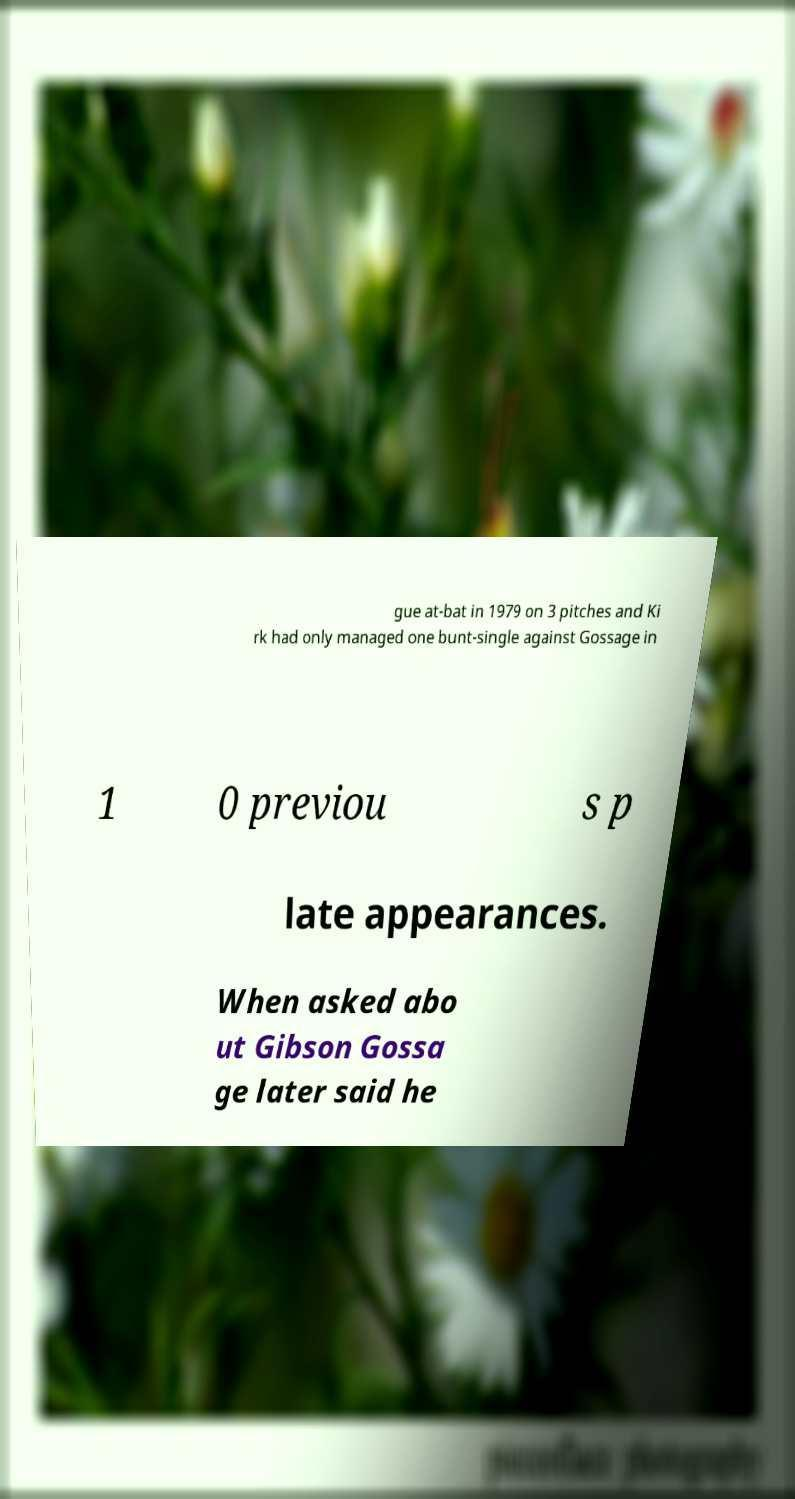What messages or text are displayed in this image? I need them in a readable, typed format. gue at-bat in 1979 on 3 pitches and Ki rk had only managed one bunt-single against Gossage in 1 0 previou s p late appearances. When asked abo ut Gibson Gossa ge later said he 